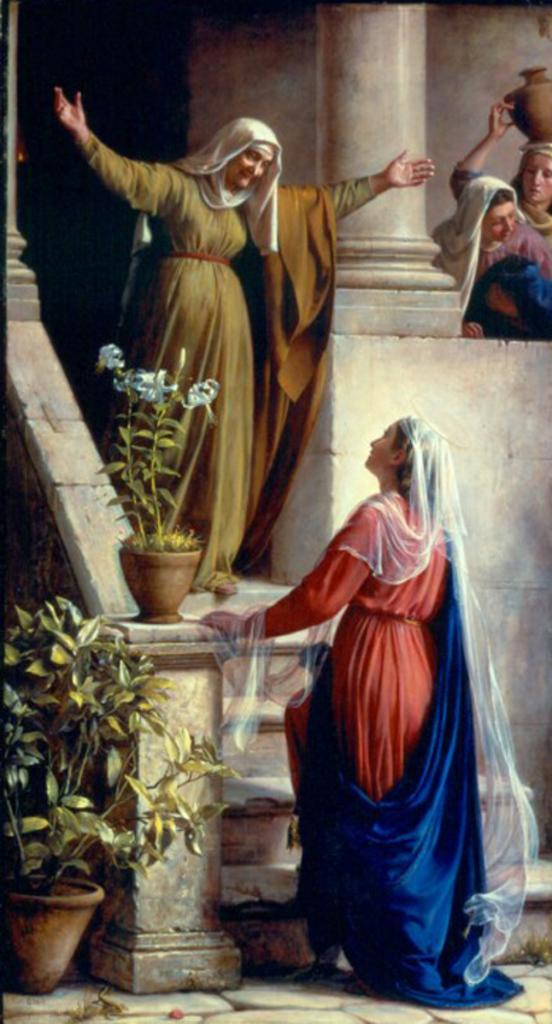How many women are present in the image? There are four women standing in the image. What else can be seen in the image besides the women? There are house plants, steps, a pillar, and a wall visible in the background of the image. What type of water feature can be seen in the image? There is no water feature present in the image. 